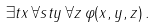<formula> <loc_0><loc_0><loc_500><loc_500>\exists t x \, \forall s t y \, \forall z \, \varphi ( x , y , z ) \, .</formula> 